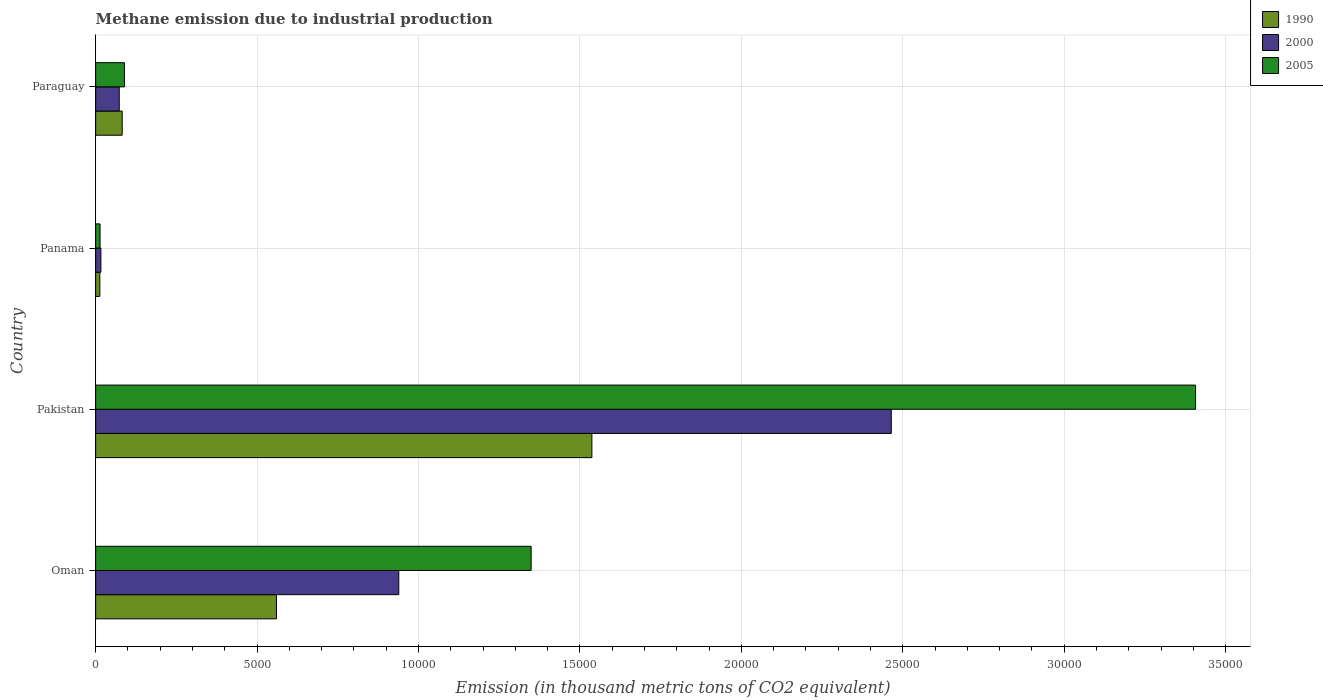How many different coloured bars are there?
Your answer should be compact. 3. How many groups of bars are there?
Make the answer very short. 4. Are the number of bars per tick equal to the number of legend labels?
Offer a very short reply. Yes. How many bars are there on the 2nd tick from the top?
Your response must be concise. 3. How many bars are there on the 2nd tick from the bottom?
Make the answer very short. 3. What is the label of the 3rd group of bars from the top?
Keep it short and to the point. Pakistan. In how many cases, is the number of bars for a given country not equal to the number of legend labels?
Make the answer very short. 0. What is the amount of methane emitted in 2000 in Oman?
Ensure brevity in your answer.  9388.4. Across all countries, what is the maximum amount of methane emitted in 1990?
Provide a succinct answer. 1.54e+04. Across all countries, what is the minimum amount of methane emitted in 1990?
Keep it short and to the point. 128.9. In which country was the amount of methane emitted in 1990 minimum?
Offer a very short reply. Panama. What is the total amount of methane emitted in 1990 in the graph?
Your response must be concise. 2.19e+04. What is the difference between the amount of methane emitted in 1990 in Oman and that in Paraguay?
Ensure brevity in your answer.  4778. What is the difference between the amount of methane emitted in 2000 in Panama and the amount of methane emitted in 2005 in Oman?
Give a very brief answer. -1.33e+04. What is the average amount of methane emitted in 2005 per country?
Your answer should be compact. 1.21e+04. What is the difference between the amount of methane emitted in 2000 and amount of methane emitted in 1990 in Pakistan?
Give a very brief answer. 9272.7. In how many countries, is the amount of methane emitted in 2005 greater than 6000 thousand metric tons?
Offer a very short reply. 2. What is the ratio of the amount of methane emitted in 2000 in Oman to that in Panama?
Give a very brief answer. 58.02. Is the difference between the amount of methane emitted in 2000 in Pakistan and Panama greater than the difference between the amount of methane emitted in 1990 in Pakistan and Panama?
Give a very brief answer. Yes. What is the difference between the highest and the second highest amount of methane emitted in 1990?
Your answer should be very brief. 9769.5. What is the difference between the highest and the lowest amount of methane emitted in 2000?
Ensure brevity in your answer.  2.45e+04. What does the 3rd bar from the top in Oman represents?
Offer a very short reply. 1990. How many bars are there?
Offer a terse response. 12. Are the values on the major ticks of X-axis written in scientific E-notation?
Give a very brief answer. No. How many legend labels are there?
Ensure brevity in your answer.  3. What is the title of the graph?
Offer a very short reply. Methane emission due to industrial production. What is the label or title of the X-axis?
Make the answer very short. Emission (in thousand metric tons of CO2 equivalent). What is the Emission (in thousand metric tons of CO2 equivalent) of 1990 in Oman?
Make the answer very short. 5599.6. What is the Emission (in thousand metric tons of CO2 equivalent) in 2000 in Oman?
Your answer should be very brief. 9388.4. What is the Emission (in thousand metric tons of CO2 equivalent) in 2005 in Oman?
Make the answer very short. 1.35e+04. What is the Emission (in thousand metric tons of CO2 equivalent) of 1990 in Pakistan?
Make the answer very short. 1.54e+04. What is the Emission (in thousand metric tons of CO2 equivalent) in 2000 in Pakistan?
Offer a very short reply. 2.46e+04. What is the Emission (in thousand metric tons of CO2 equivalent) of 2005 in Pakistan?
Your response must be concise. 3.41e+04. What is the Emission (in thousand metric tons of CO2 equivalent) of 1990 in Panama?
Offer a terse response. 128.9. What is the Emission (in thousand metric tons of CO2 equivalent) in 2000 in Panama?
Provide a short and direct response. 161.8. What is the Emission (in thousand metric tons of CO2 equivalent) of 2005 in Panama?
Provide a short and direct response. 135.8. What is the Emission (in thousand metric tons of CO2 equivalent) in 1990 in Paraguay?
Keep it short and to the point. 821.6. What is the Emission (in thousand metric tons of CO2 equivalent) of 2000 in Paraguay?
Ensure brevity in your answer.  730.2. What is the Emission (in thousand metric tons of CO2 equivalent) of 2005 in Paraguay?
Give a very brief answer. 891.9. Across all countries, what is the maximum Emission (in thousand metric tons of CO2 equivalent) of 1990?
Your answer should be compact. 1.54e+04. Across all countries, what is the maximum Emission (in thousand metric tons of CO2 equivalent) of 2000?
Give a very brief answer. 2.46e+04. Across all countries, what is the maximum Emission (in thousand metric tons of CO2 equivalent) in 2005?
Provide a short and direct response. 3.41e+04. Across all countries, what is the minimum Emission (in thousand metric tons of CO2 equivalent) of 1990?
Ensure brevity in your answer.  128.9. Across all countries, what is the minimum Emission (in thousand metric tons of CO2 equivalent) in 2000?
Offer a terse response. 161.8. Across all countries, what is the minimum Emission (in thousand metric tons of CO2 equivalent) in 2005?
Offer a very short reply. 135.8. What is the total Emission (in thousand metric tons of CO2 equivalent) of 1990 in the graph?
Your response must be concise. 2.19e+04. What is the total Emission (in thousand metric tons of CO2 equivalent) in 2000 in the graph?
Provide a succinct answer. 3.49e+04. What is the total Emission (in thousand metric tons of CO2 equivalent) of 2005 in the graph?
Offer a very short reply. 4.86e+04. What is the difference between the Emission (in thousand metric tons of CO2 equivalent) of 1990 in Oman and that in Pakistan?
Your answer should be compact. -9769.5. What is the difference between the Emission (in thousand metric tons of CO2 equivalent) of 2000 in Oman and that in Pakistan?
Provide a short and direct response. -1.53e+04. What is the difference between the Emission (in thousand metric tons of CO2 equivalent) of 2005 in Oman and that in Pakistan?
Provide a short and direct response. -2.06e+04. What is the difference between the Emission (in thousand metric tons of CO2 equivalent) in 1990 in Oman and that in Panama?
Provide a short and direct response. 5470.7. What is the difference between the Emission (in thousand metric tons of CO2 equivalent) of 2000 in Oman and that in Panama?
Provide a succinct answer. 9226.6. What is the difference between the Emission (in thousand metric tons of CO2 equivalent) in 2005 in Oman and that in Panama?
Provide a short and direct response. 1.34e+04. What is the difference between the Emission (in thousand metric tons of CO2 equivalent) of 1990 in Oman and that in Paraguay?
Ensure brevity in your answer.  4778. What is the difference between the Emission (in thousand metric tons of CO2 equivalent) of 2000 in Oman and that in Paraguay?
Keep it short and to the point. 8658.2. What is the difference between the Emission (in thousand metric tons of CO2 equivalent) in 2005 in Oman and that in Paraguay?
Provide a succinct answer. 1.26e+04. What is the difference between the Emission (in thousand metric tons of CO2 equivalent) in 1990 in Pakistan and that in Panama?
Provide a short and direct response. 1.52e+04. What is the difference between the Emission (in thousand metric tons of CO2 equivalent) of 2000 in Pakistan and that in Panama?
Your response must be concise. 2.45e+04. What is the difference between the Emission (in thousand metric tons of CO2 equivalent) in 2005 in Pakistan and that in Panama?
Offer a very short reply. 3.39e+04. What is the difference between the Emission (in thousand metric tons of CO2 equivalent) in 1990 in Pakistan and that in Paraguay?
Provide a short and direct response. 1.45e+04. What is the difference between the Emission (in thousand metric tons of CO2 equivalent) of 2000 in Pakistan and that in Paraguay?
Keep it short and to the point. 2.39e+04. What is the difference between the Emission (in thousand metric tons of CO2 equivalent) in 2005 in Pakistan and that in Paraguay?
Make the answer very short. 3.32e+04. What is the difference between the Emission (in thousand metric tons of CO2 equivalent) in 1990 in Panama and that in Paraguay?
Give a very brief answer. -692.7. What is the difference between the Emission (in thousand metric tons of CO2 equivalent) of 2000 in Panama and that in Paraguay?
Offer a very short reply. -568.4. What is the difference between the Emission (in thousand metric tons of CO2 equivalent) in 2005 in Panama and that in Paraguay?
Give a very brief answer. -756.1. What is the difference between the Emission (in thousand metric tons of CO2 equivalent) of 1990 in Oman and the Emission (in thousand metric tons of CO2 equivalent) of 2000 in Pakistan?
Your answer should be compact. -1.90e+04. What is the difference between the Emission (in thousand metric tons of CO2 equivalent) in 1990 in Oman and the Emission (in thousand metric tons of CO2 equivalent) in 2005 in Pakistan?
Ensure brevity in your answer.  -2.85e+04. What is the difference between the Emission (in thousand metric tons of CO2 equivalent) in 2000 in Oman and the Emission (in thousand metric tons of CO2 equivalent) in 2005 in Pakistan?
Offer a very short reply. -2.47e+04. What is the difference between the Emission (in thousand metric tons of CO2 equivalent) of 1990 in Oman and the Emission (in thousand metric tons of CO2 equivalent) of 2000 in Panama?
Your answer should be compact. 5437.8. What is the difference between the Emission (in thousand metric tons of CO2 equivalent) in 1990 in Oman and the Emission (in thousand metric tons of CO2 equivalent) in 2005 in Panama?
Make the answer very short. 5463.8. What is the difference between the Emission (in thousand metric tons of CO2 equivalent) of 2000 in Oman and the Emission (in thousand metric tons of CO2 equivalent) of 2005 in Panama?
Provide a short and direct response. 9252.6. What is the difference between the Emission (in thousand metric tons of CO2 equivalent) of 1990 in Oman and the Emission (in thousand metric tons of CO2 equivalent) of 2000 in Paraguay?
Provide a short and direct response. 4869.4. What is the difference between the Emission (in thousand metric tons of CO2 equivalent) in 1990 in Oman and the Emission (in thousand metric tons of CO2 equivalent) in 2005 in Paraguay?
Ensure brevity in your answer.  4707.7. What is the difference between the Emission (in thousand metric tons of CO2 equivalent) in 2000 in Oman and the Emission (in thousand metric tons of CO2 equivalent) in 2005 in Paraguay?
Your response must be concise. 8496.5. What is the difference between the Emission (in thousand metric tons of CO2 equivalent) in 1990 in Pakistan and the Emission (in thousand metric tons of CO2 equivalent) in 2000 in Panama?
Offer a very short reply. 1.52e+04. What is the difference between the Emission (in thousand metric tons of CO2 equivalent) in 1990 in Pakistan and the Emission (in thousand metric tons of CO2 equivalent) in 2005 in Panama?
Keep it short and to the point. 1.52e+04. What is the difference between the Emission (in thousand metric tons of CO2 equivalent) of 2000 in Pakistan and the Emission (in thousand metric tons of CO2 equivalent) of 2005 in Panama?
Give a very brief answer. 2.45e+04. What is the difference between the Emission (in thousand metric tons of CO2 equivalent) of 1990 in Pakistan and the Emission (in thousand metric tons of CO2 equivalent) of 2000 in Paraguay?
Your answer should be very brief. 1.46e+04. What is the difference between the Emission (in thousand metric tons of CO2 equivalent) of 1990 in Pakistan and the Emission (in thousand metric tons of CO2 equivalent) of 2005 in Paraguay?
Your answer should be compact. 1.45e+04. What is the difference between the Emission (in thousand metric tons of CO2 equivalent) of 2000 in Pakistan and the Emission (in thousand metric tons of CO2 equivalent) of 2005 in Paraguay?
Offer a terse response. 2.37e+04. What is the difference between the Emission (in thousand metric tons of CO2 equivalent) of 1990 in Panama and the Emission (in thousand metric tons of CO2 equivalent) of 2000 in Paraguay?
Provide a succinct answer. -601.3. What is the difference between the Emission (in thousand metric tons of CO2 equivalent) of 1990 in Panama and the Emission (in thousand metric tons of CO2 equivalent) of 2005 in Paraguay?
Provide a short and direct response. -763. What is the difference between the Emission (in thousand metric tons of CO2 equivalent) of 2000 in Panama and the Emission (in thousand metric tons of CO2 equivalent) of 2005 in Paraguay?
Your answer should be very brief. -730.1. What is the average Emission (in thousand metric tons of CO2 equivalent) in 1990 per country?
Your answer should be very brief. 5479.8. What is the average Emission (in thousand metric tons of CO2 equivalent) in 2000 per country?
Keep it short and to the point. 8730.55. What is the average Emission (in thousand metric tons of CO2 equivalent) in 2005 per country?
Make the answer very short. 1.21e+04. What is the difference between the Emission (in thousand metric tons of CO2 equivalent) of 1990 and Emission (in thousand metric tons of CO2 equivalent) of 2000 in Oman?
Your answer should be very brief. -3788.8. What is the difference between the Emission (in thousand metric tons of CO2 equivalent) in 1990 and Emission (in thousand metric tons of CO2 equivalent) in 2005 in Oman?
Provide a succinct answer. -7887.8. What is the difference between the Emission (in thousand metric tons of CO2 equivalent) in 2000 and Emission (in thousand metric tons of CO2 equivalent) in 2005 in Oman?
Your response must be concise. -4099. What is the difference between the Emission (in thousand metric tons of CO2 equivalent) in 1990 and Emission (in thousand metric tons of CO2 equivalent) in 2000 in Pakistan?
Your response must be concise. -9272.7. What is the difference between the Emission (in thousand metric tons of CO2 equivalent) in 1990 and Emission (in thousand metric tons of CO2 equivalent) in 2005 in Pakistan?
Your answer should be very brief. -1.87e+04. What is the difference between the Emission (in thousand metric tons of CO2 equivalent) in 2000 and Emission (in thousand metric tons of CO2 equivalent) in 2005 in Pakistan?
Offer a terse response. -9424.3. What is the difference between the Emission (in thousand metric tons of CO2 equivalent) of 1990 and Emission (in thousand metric tons of CO2 equivalent) of 2000 in Panama?
Give a very brief answer. -32.9. What is the difference between the Emission (in thousand metric tons of CO2 equivalent) in 2000 and Emission (in thousand metric tons of CO2 equivalent) in 2005 in Panama?
Make the answer very short. 26. What is the difference between the Emission (in thousand metric tons of CO2 equivalent) in 1990 and Emission (in thousand metric tons of CO2 equivalent) in 2000 in Paraguay?
Keep it short and to the point. 91.4. What is the difference between the Emission (in thousand metric tons of CO2 equivalent) in 1990 and Emission (in thousand metric tons of CO2 equivalent) in 2005 in Paraguay?
Offer a terse response. -70.3. What is the difference between the Emission (in thousand metric tons of CO2 equivalent) of 2000 and Emission (in thousand metric tons of CO2 equivalent) of 2005 in Paraguay?
Your answer should be very brief. -161.7. What is the ratio of the Emission (in thousand metric tons of CO2 equivalent) in 1990 in Oman to that in Pakistan?
Your answer should be compact. 0.36. What is the ratio of the Emission (in thousand metric tons of CO2 equivalent) in 2000 in Oman to that in Pakistan?
Keep it short and to the point. 0.38. What is the ratio of the Emission (in thousand metric tons of CO2 equivalent) of 2005 in Oman to that in Pakistan?
Offer a very short reply. 0.4. What is the ratio of the Emission (in thousand metric tons of CO2 equivalent) of 1990 in Oman to that in Panama?
Provide a succinct answer. 43.44. What is the ratio of the Emission (in thousand metric tons of CO2 equivalent) of 2000 in Oman to that in Panama?
Give a very brief answer. 58.02. What is the ratio of the Emission (in thousand metric tons of CO2 equivalent) of 2005 in Oman to that in Panama?
Keep it short and to the point. 99.32. What is the ratio of the Emission (in thousand metric tons of CO2 equivalent) of 1990 in Oman to that in Paraguay?
Provide a short and direct response. 6.82. What is the ratio of the Emission (in thousand metric tons of CO2 equivalent) in 2000 in Oman to that in Paraguay?
Give a very brief answer. 12.86. What is the ratio of the Emission (in thousand metric tons of CO2 equivalent) of 2005 in Oman to that in Paraguay?
Your response must be concise. 15.12. What is the ratio of the Emission (in thousand metric tons of CO2 equivalent) in 1990 in Pakistan to that in Panama?
Your answer should be very brief. 119.23. What is the ratio of the Emission (in thousand metric tons of CO2 equivalent) in 2000 in Pakistan to that in Panama?
Your response must be concise. 152.3. What is the ratio of the Emission (in thousand metric tons of CO2 equivalent) in 2005 in Pakistan to that in Panama?
Offer a very short reply. 250.85. What is the ratio of the Emission (in thousand metric tons of CO2 equivalent) in 1990 in Pakistan to that in Paraguay?
Offer a terse response. 18.71. What is the ratio of the Emission (in thousand metric tons of CO2 equivalent) of 2000 in Pakistan to that in Paraguay?
Offer a very short reply. 33.75. What is the ratio of the Emission (in thousand metric tons of CO2 equivalent) of 2005 in Pakistan to that in Paraguay?
Offer a very short reply. 38.2. What is the ratio of the Emission (in thousand metric tons of CO2 equivalent) of 1990 in Panama to that in Paraguay?
Keep it short and to the point. 0.16. What is the ratio of the Emission (in thousand metric tons of CO2 equivalent) of 2000 in Panama to that in Paraguay?
Keep it short and to the point. 0.22. What is the ratio of the Emission (in thousand metric tons of CO2 equivalent) of 2005 in Panama to that in Paraguay?
Make the answer very short. 0.15. What is the difference between the highest and the second highest Emission (in thousand metric tons of CO2 equivalent) of 1990?
Keep it short and to the point. 9769.5. What is the difference between the highest and the second highest Emission (in thousand metric tons of CO2 equivalent) of 2000?
Your answer should be compact. 1.53e+04. What is the difference between the highest and the second highest Emission (in thousand metric tons of CO2 equivalent) in 2005?
Provide a succinct answer. 2.06e+04. What is the difference between the highest and the lowest Emission (in thousand metric tons of CO2 equivalent) of 1990?
Your answer should be compact. 1.52e+04. What is the difference between the highest and the lowest Emission (in thousand metric tons of CO2 equivalent) of 2000?
Provide a succinct answer. 2.45e+04. What is the difference between the highest and the lowest Emission (in thousand metric tons of CO2 equivalent) of 2005?
Provide a short and direct response. 3.39e+04. 